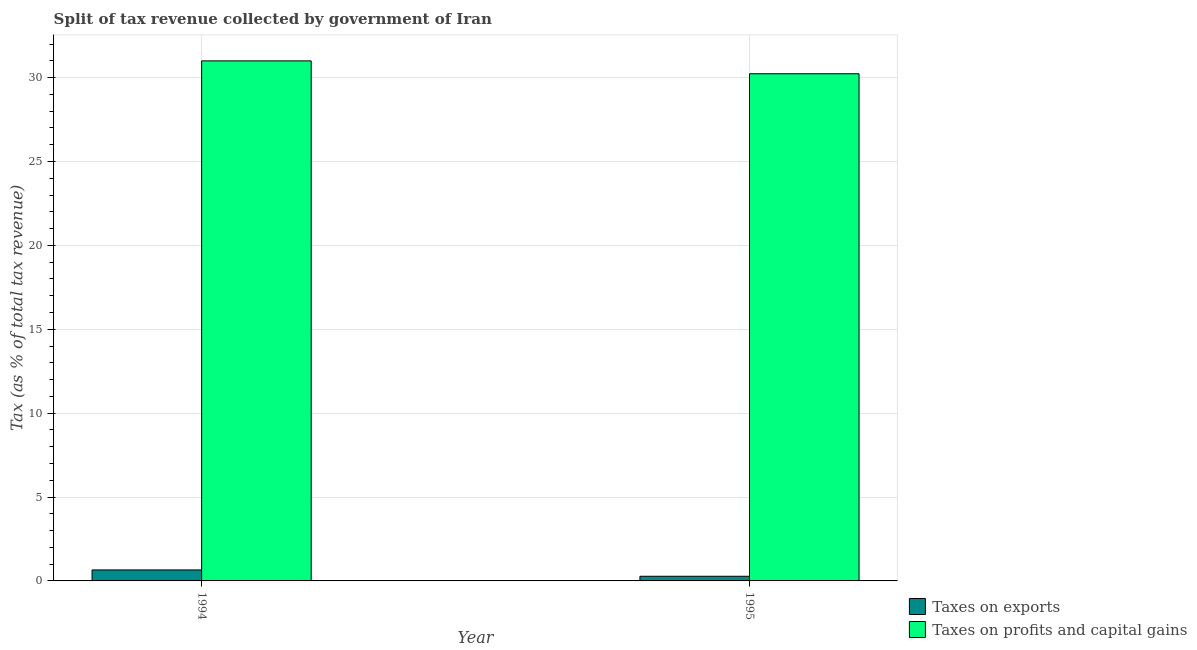How many groups of bars are there?
Give a very brief answer. 2. Are the number of bars per tick equal to the number of legend labels?
Offer a terse response. Yes. Are the number of bars on each tick of the X-axis equal?
Your answer should be compact. Yes. How many bars are there on the 1st tick from the left?
Give a very brief answer. 2. How many bars are there on the 1st tick from the right?
Your answer should be compact. 2. What is the percentage of revenue obtained from taxes on profits and capital gains in 1995?
Offer a terse response. 30.23. Across all years, what is the maximum percentage of revenue obtained from taxes on profits and capital gains?
Your answer should be compact. 31. Across all years, what is the minimum percentage of revenue obtained from taxes on profits and capital gains?
Make the answer very short. 30.23. In which year was the percentage of revenue obtained from taxes on profits and capital gains minimum?
Your response must be concise. 1995. What is the total percentage of revenue obtained from taxes on profits and capital gains in the graph?
Your answer should be very brief. 61.23. What is the difference between the percentage of revenue obtained from taxes on profits and capital gains in 1994 and that in 1995?
Ensure brevity in your answer.  0.77. What is the difference between the percentage of revenue obtained from taxes on profits and capital gains in 1994 and the percentage of revenue obtained from taxes on exports in 1995?
Your answer should be very brief. 0.77. What is the average percentage of revenue obtained from taxes on profits and capital gains per year?
Provide a succinct answer. 30.62. In the year 1995, what is the difference between the percentage of revenue obtained from taxes on exports and percentage of revenue obtained from taxes on profits and capital gains?
Make the answer very short. 0. What is the ratio of the percentage of revenue obtained from taxes on profits and capital gains in 1994 to that in 1995?
Give a very brief answer. 1.03. Is the percentage of revenue obtained from taxes on profits and capital gains in 1994 less than that in 1995?
Offer a terse response. No. In how many years, is the percentage of revenue obtained from taxes on exports greater than the average percentage of revenue obtained from taxes on exports taken over all years?
Keep it short and to the point. 1. What does the 1st bar from the left in 1994 represents?
Your response must be concise. Taxes on exports. What does the 1st bar from the right in 1994 represents?
Keep it short and to the point. Taxes on profits and capital gains. How many bars are there?
Provide a succinct answer. 4. Are all the bars in the graph horizontal?
Provide a succinct answer. No. What is the difference between two consecutive major ticks on the Y-axis?
Give a very brief answer. 5. Are the values on the major ticks of Y-axis written in scientific E-notation?
Your answer should be compact. No. Does the graph contain any zero values?
Make the answer very short. No. What is the title of the graph?
Your answer should be compact. Split of tax revenue collected by government of Iran. Does "Death rate" appear as one of the legend labels in the graph?
Provide a succinct answer. No. What is the label or title of the X-axis?
Offer a terse response. Year. What is the label or title of the Y-axis?
Your answer should be very brief. Tax (as % of total tax revenue). What is the Tax (as % of total tax revenue) in Taxes on exports in 1994?
Keep it short and to the point. 0.65. What is the Tax (as % of total tax revenue) in Taxes on profits and capital gains in 1994?
Your answer should be very brief. 31. What is the Tax (as % of total tax revenue) in Taxes on exports in 1995?
Ensure brevity in your answer.  0.28. What is the Tax (as % of total tax revenue) of Taxes on profits and capital gains in 1995?
Keep it short and to the point. 30.23. Across all years, what is the maximum Tax (as % of total tax revenue) in Taxes on exports?
Provide a succinct answer. 0.65. Across all years, what is the maximum Tax (as % of total tax revenue) in Taxes on profits and capital gains?
Provide a short and direct response. 31. Across all years, what is the minimum Tax (as % of total tax revenue) in Taxes on exports?
Make the answer very short. 0.28. Across all years, what is the minimum Tax (as % of total tax revenue) in Taxes on profits and capital gains?
Your answer should be very brief. 30.23. What is the total Tax (as % of total tax revenue) in Taxes on exports in the graph?
Ensure brevity in your answer.  0.93. What is the total Tax (as % of total tax revenue) of Taxes on profits and capital gains in the graph?
Give a very brief answer. 61.23. What is the difference between the Tax (as % of total tax revenue) in Taxes on exports in 1994 and that in 1995?
Make the answer very short. 0.38. What is the difference between the Tax (as % of total tax revenue) of Taxes on profits and capital gains in 1994 and that in 1995?
Your answer should be compact. 0.77. What is the difference between the Tax (as % of total tax revenue) of Taxes on exports in 1994 and the Tax (as % of total tax revenue) of Taxes on profits and capital gains in 1995?
Ensure brevity in your answer.  -29.58. What is the average Tax (as % of total tax revenue) of Taxes on exports per year?
Provide a short and direct response. 0.47. What is the average Tax (as % of total tax revenue) in Taxes on profits and capital gains per year?
Keep it short and to the point. 30.62. In the year 1994, what is the difference between the Tax (as % of total tax revenue) of Taxes on exports and Tax (as % of total tax revenue) of Taxes on profits and capital gains?
Offer a terse response. -30.35. In the year 1995, what is the difference between the Tax (as % of total tax revenue) of Taxes on exports and Tax (as % of total tax revenue) of Taxes on profits and capital gains?
Make the answer very short. -29.96. What is the ratio of the Tax (as % of total tax revenue) of Taxes on exports in 1994 to that in 1995?
Your response must be concise. 2.36. What is the ratio of the Tax (as % of total tax revenue) of Taxes on profits and capital gains in 1994 to that in 1995?
Provide a short and direct response. 1.03. What is the difference between the highest and the second highest Tax (as % of total tax revenue) of Taxes on exports?
Your answer should be compact. 0.38. What is the difference between the highest and the second highest Tax (as % of total tax revenue) in Taxes on profits and capital gains?
Offer a terse response. 0.77. What is the difference between the highest and the lowest Tax (as % of total tax revenue) in Taxes on exports?
Your answer should be very brief. 0.38. What is the difference between the highest and the lowest Tax (as % of total tax revenue) in Taxes on profits and capital gains?
Keep it short and to the point. 0.77. 